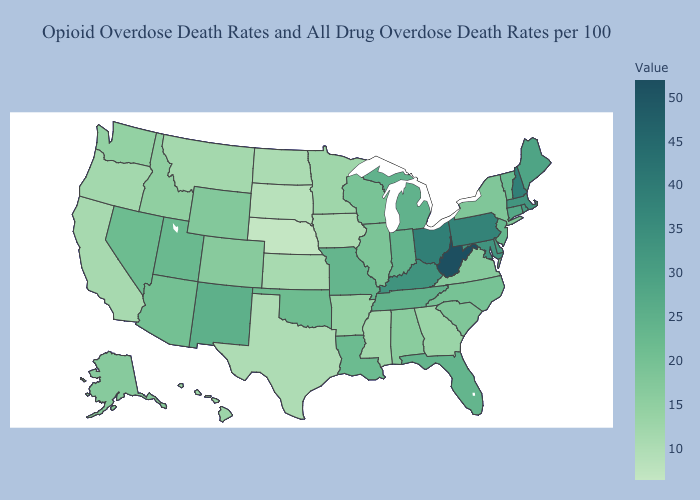Does Minnesota have a higher value than South Carolina?
Answer briefly. No. Is the legend a continuous bar?
Write a very short answer. Yes. Among the states that border Wyoming , does Colorado have the lowest value?
Concise answer only. No. Does West Virginia have the highest value in the USA?
Short answer required. Yes. 